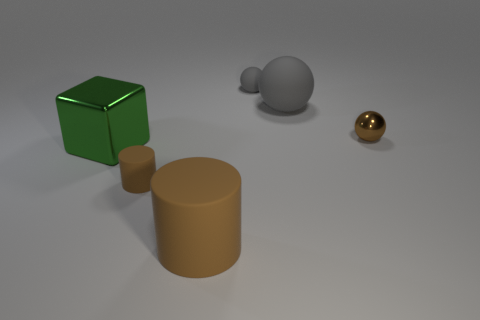Are there any large green metal objects right of the shiny object that is on the left side of the tiny brown shiny object?
Offer a very short reply. No. Are there any brown matte things that have the same shape as the big green metal object?
Offer a very short reply. No. There is a matte cylinder that is behind the cylinder that is in front of the small rubber cylinder; how many large rubber cylinders are on the left side of it?
Give a very brief answer. 0. Do the cube and the ball on the right side of the large gray matte thing have the same color?
Your answer should be very brief. No. What number of things are cylinders that are in front of the small cylinder or metal objects to the right of the tiny brown rubber cylinder?
Your response must be concise. 2. Is the number of tiny brown matte cylinders that are on the right side of the big brown rubber cylinder greater than the number of small brown things that are to the right of the big sphere?
Provide a succinct answer. No. The big green block on the left side of the big matte thing that is on the right side of the rubber cylinder in front of the tiny brown cylinder is made of what material?
Offer a very short reply. Metal. Is the shape of the large object that is behind the shiny block the same as the large matte object that is in front of the cube?
Your answer should be very brief. No. Are there any other things of the same size as the green metal thing?
Make the answer very short. Yes. How many gray things are large objects or big matte cylinders?
Keep it short and to the point. 1. 